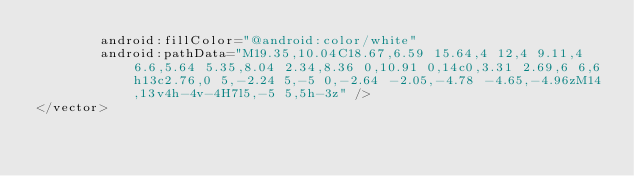<code> <loc_0><loc_0><loc_500><loc_500><_XML_>        android:fillColor="@android:color/white"
        android:pathData="M19.35,10.04C18.67,6.59 15.64,4 12,4 9.11,4 6.6,5.64 5.35,8.04 2.34,8.36 0,10.91 0,14c0,3.31 2.69,6 6,6h13c2.76,0 5,-2.24 5,-5 0,-2.64 -2.05,-4.78 -4.65,-4.96zM14,13v4h-4v-4H7l5,-5 5,5h-3z" />
</vector>
</code> 